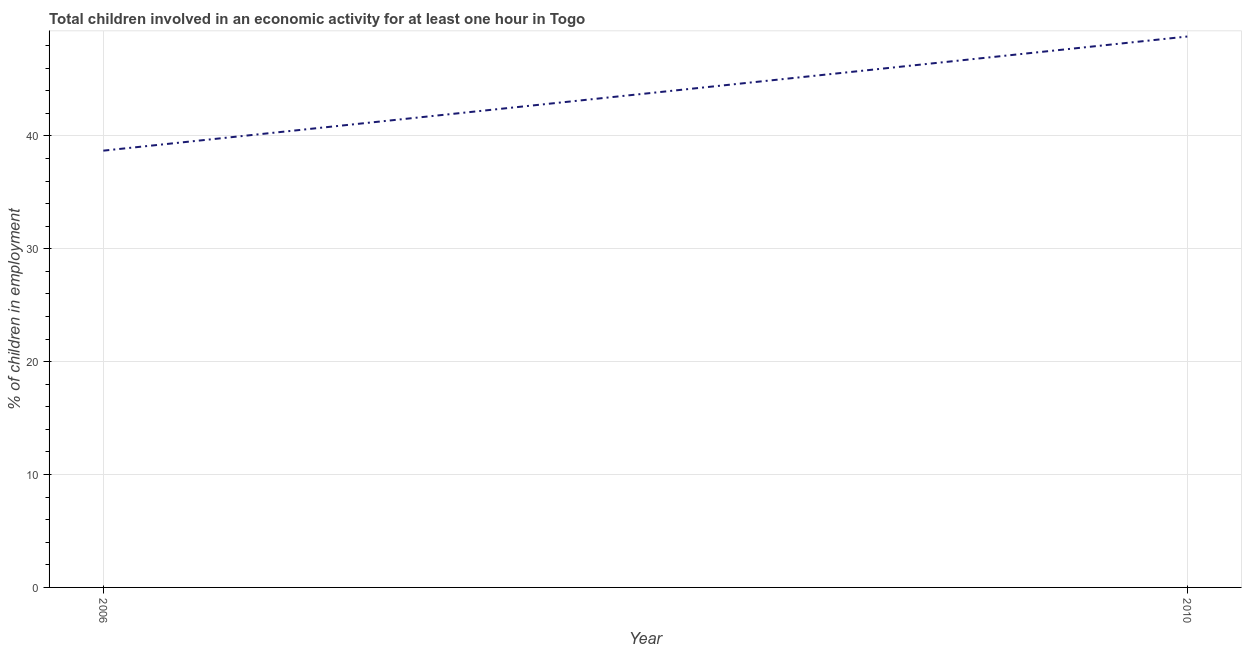What is the percentage of children in employment in 2010?
Provide a short and direct response. 48.8. Across all years, what is the maximum percentage of children in employment?
Give a very brief answer. 48.8. Across all years, what is the minimum percentage of children in employment?
Offer a terse response. 38.69. What is the sum of the percentage of children in employment?
Your response must be concise. 87.49. What is the difference between the percentage of children in employment in 2006 and 2010?
Your answer should be very brief. -10.11. What is the average percentage of children in employment per year?
Give a very brief answer. 43.74. What is the median percentage of children in employment?
Give a very brief answer. 43.74. Do a majority of the years between 2010 and 2006 (inclusive) have percentage of children in employment greater than 10 %?
Keep it short and to the point. No. What is the ratio of the percentage of children in employment in 2006 to that in 2010?
Give a very brief answer. 0.79. In how many years, is the percentage of children in employment greater than the average percentage of children in employment taken over all years?
Provide a succinct answer. 1. How many years are there in the graph?
Ensure brevity in your answer.  2. What is the difference between two consecutive major ticks on the Y-axis?
Provide a short and direct response. 10. Are the values on the major ticks of Y-axis written in scientific E-notation?
Ensure brevity in your answer.  No. Does the graph contain grids?
Provide a short and direct response. Yes. What is the title of the graph?
Make the answer very short. Total children involved in an economic activity for at least one hour in Togo. What is the label or title of the X-axis?
Your answer should be very brief. Year. What is the label or title of the Y-axis?
Your answer should be compact. % of children in employment. What is the % of children in employment in 2006?
Your answer should be very brief. 38.69. What is the % of children in employment of 2010?
Provide a short and direct response. 48.8. What is the difference between the % of children in employment in 2006 and 2010?
Offer a very short reply. -10.11. What is the ratio of the % of children in employment in 2006 to that in 2010?
Offer a very short reply. 0.79. 